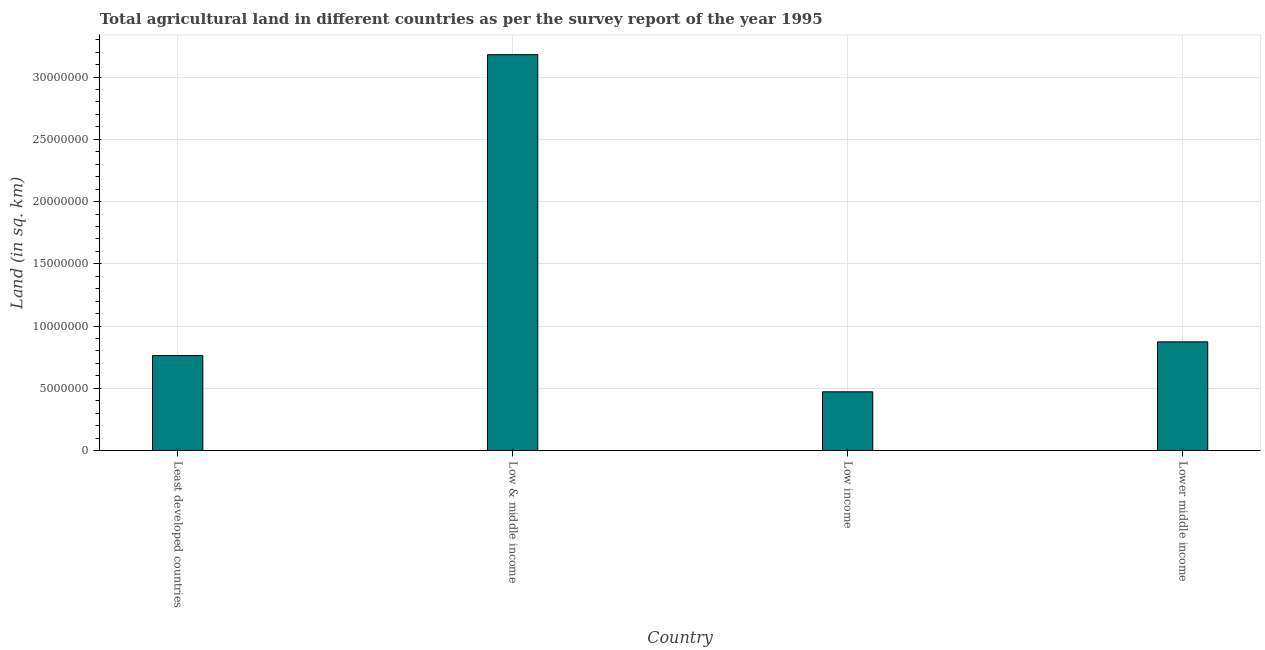Does the graph contain any zero values?
Your response must be concise. No. Does the graph contain grids?
Give a very brief answer. Yes. What is the title of the graph?
Your answer should be very brief. Total agricultural land in different countries as per the survey report of the year 1995. What is the label or title of the X-axis?
Offer a very short reply. Country. What is the label or title of the Y-axis?
Give a very brief answer. Land (in sq. km). What is the agricultural land in Low & middle income?
Provide a short and direct response. 3.18e+07. Across all countries, what is the maximum agricultural land?
Provide a succinct answer. 3.18e+07. Across all countries, what is the minimum agricultural land?
Your answer should be very brief. 4.72e+06. In which country was the agricultural land minimum?
Make the answer very short. Low income. What is the sum of the agricultural land?
Offer a very short reply. 5.29e+07. What is the difference between the agricultural land in Low & middle income and Low income?
Offer a terse response. 2.71e+07. What is the average agricultural land per country?
Provide a short and direct response. 1.32e+07. What is the median agricultural land?
Ensure brevity in your answer.  8.18e+06. In how many countries, is the agricultural land greater than 25000000 sq. km?
Provide a succinct answer. 1. What is the ratio of the agricultural land in Least developed countries to that in Lower middle income?
Keep it short and to the point. 0.87. Is the agricultural land in Least developed countries less than that in Low & middle income?
Your response must be concise. Yes. Is the difference between the agricultural land in Low income and Lower middle income greater than the difference between any two countries?
Provide a short and direct response. No. What is the difference between the highest and the second highest agricultural land?
Offer a terse response. 2.31e+07. What is the difference between the highest and the lowest agricultural land?
Provide a short and direct response. 2.71e+07. How many countries are there in the graph?
Your answer should be compact. 4. What is the Land (in sq. km) of Least developed countries?
Make the answer very short. 7.63e+06. What is the Land (in sq. km) of Low & middle income?
Your response must be concise. 3.18e+07. What is the Land (in sq. km) in Low income?
Ensure brevity in your answer.  4.72e+06. What is the Land (in sq. km) in Lower middle income?
Offer a terse response. 8.73e+06. What is the difference between the Land (in sq. km) in Least developed countries and Low & middle income?
Provide a short and direct response. -2.42e+07. What is the difference between the Land (in sq. km) in Least developed countries and Low income?
Keep it short and to the point. 2.91e+06. What is the difference between the Land (in sq. km) in Least developed countries and Lower middle income?
Give a very brief answer. -1.10e+06. What is the difference between the Land (in sq. km) in Low & middle income and Low income?
Give a very brief answer. 2.71e+07. What is the difference between the Land (in sq. km) in Low & middle income and Lower middle income?
Provide a succinct answer. 2.31e+07. What is the difference between the Land (in sq. km) in Low income and Lower middle income?
Keep it short and to the point. -4.01e+06. What is the ratio of the Land (in sq. km) in Least developed countries to that in Low & middle income?
Your answer should be very brief. 0.24. What is the ratio of the Land (in sq. km) in Least developed countries to that in Low income?
Keep it short and to the point. 1.62. What is the ratio of the Land (in sq. km) in Least developed countries to that in Lower middle income?
Keep it short and to the point. 0.87. What is the ratio of the Land (in sq. km) in Low & middle income to that in Low income?
Provide a succinct answer. 6.75. What is the ratio of the Land (in sq. km) in Low & middle income to that in Lower middle income?
Give a very brief answer. 3.64. What is the ratio of the Land (in sq. km) in Low income to that in Lower middle income?
Your answer should be compact. 0.54. 